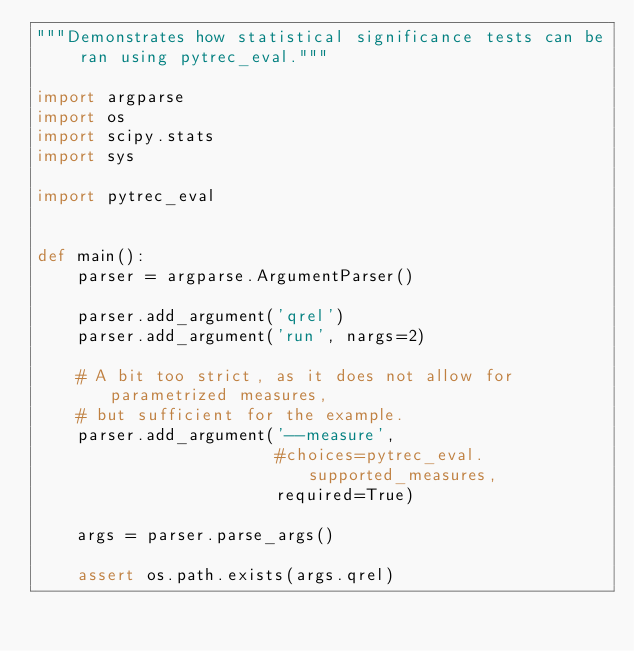<code> <loc_0><loc_0><loc_500><loc_500><_Python_>"""Demonstrates how statistical significance tests can be ran using pytrec_eval."""

import argparse
import os
import scipy.stats
import sys

import pytrec_eval


def main():
    parser = argparse.ArgumentParser()

    parser.add_argument('qrel')
    parser.add_argument('run', nargs=2)

    # A bit too strict, as it does not allow for parametrized measures,
    # but sufficient for the example.
    parser.add_argument('--measure',
                        #choices=pytrec_eval.supported_measures,
                        required=True)

    args = parser.parse_args()

    assert os.path.exists(args.qrel)</code> 